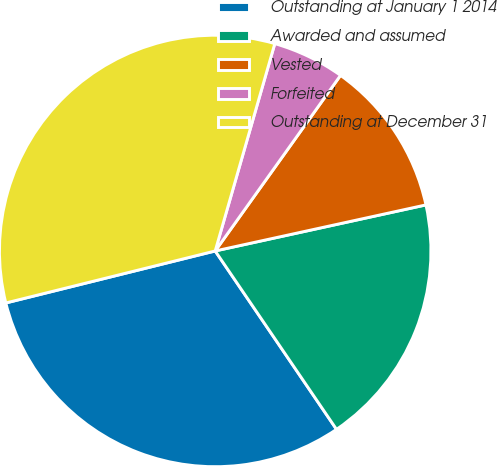<chart> <loc_0><loc_0><loc_500><loc_500><pie_chart><fcel>Outstanding at January 1 2014<fcel>Awarded and assumed<fcel>Vested<fcel>Forfeited<fcel>Outstanding at December 31<nl><fcel>30.63%<fcel>18.92%<fcel>11.71%<fcel>5.41%<fcel>33.33%<nl></chart> 